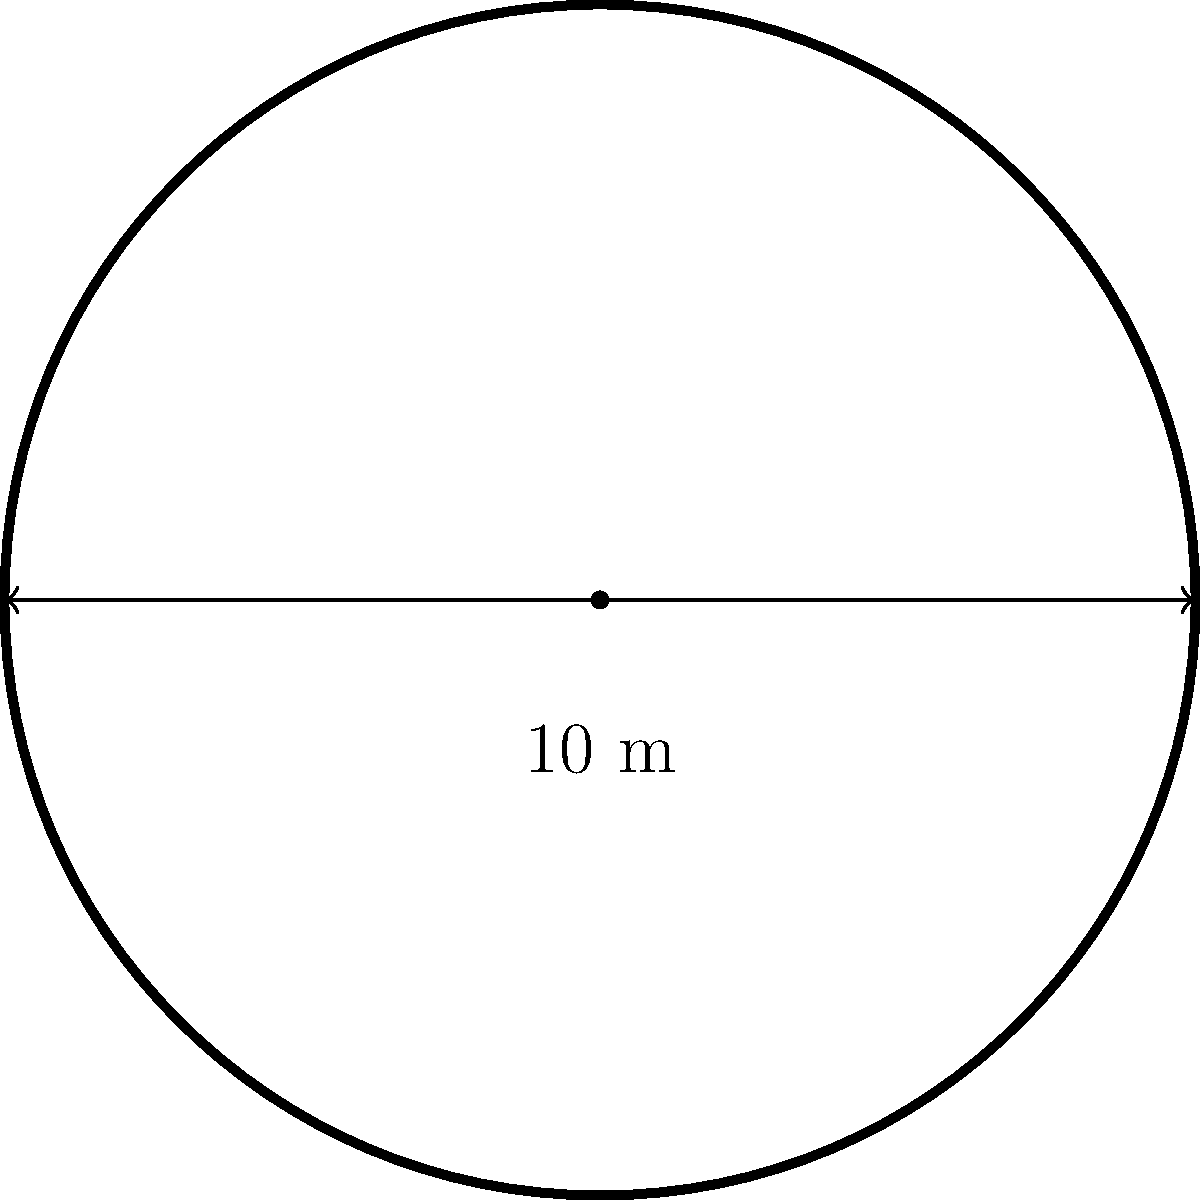As a tournament director, you need to calculate the area of a circular tennis court for a prestigious competition. Given that the diameter of the court is 10 meters, what is the area of the court in square meters? Round your answer to two decimal places. To calculate the area of a circular tennis court, we can use the formula for the area of a circle:

$$A = \pi r^2$$

Where:
$A$ is the area of the circle
$\pi$ is approximately 3.14159
$r$ is the radius of the circle

Steps to solve:

1. Find the radius:
   The diameter is given as 10 meters. The radius is half of the diameter.
   $$r = \frac{10}{2} = 5\text{ meters}$$

2. Apply the formula:
   $$A = \pi r^2$$
   $$A = \pi \cdot (5\text{ m})^2$$
   $$A = \pi \cdot 25\text{ m}^2$$

3. Calculate and round to two decimal places:
   $$A \approx 3.14159 \cdot 25\text{ m}^2$$
   $$A \approx 78.53975\text{ m}^2$$
   $$A \approx 78.54\text{ m}^2\text{ (rounded to two decimal places)}$$

Therefore, the area of the circular tennis court is approximately 78.54 square meters.
Answer: $78.54\text{ m}^2$ 